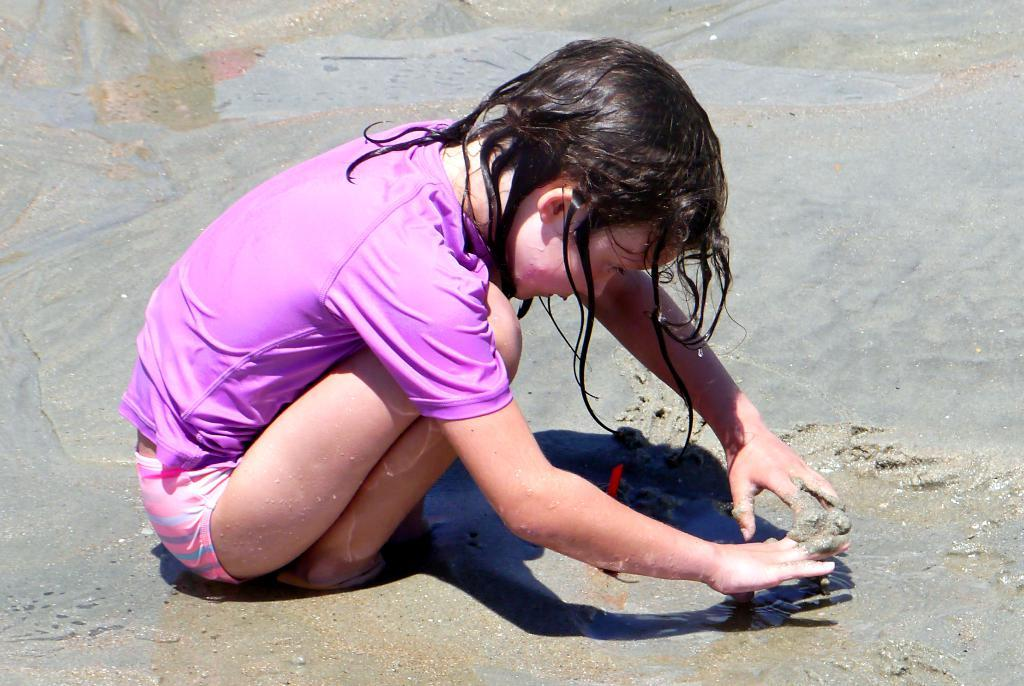What is the main subject of the image? There is a child in the image. What type of environment is depicted in the image? The image shows a sandy and watery environment. Can you see the child's aunt in the image? There is no mention of an aunt in the image, so we cannot determine if the child's aunt is present. Is there a horse in the image? There is no mention of a horse in the image, so we cannot determine if a horse is present. 